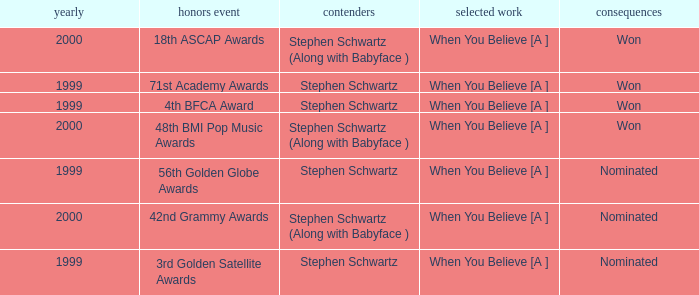Which Nominated Work won in 2000? When You Believe [A ], When You Believe [A ]. 